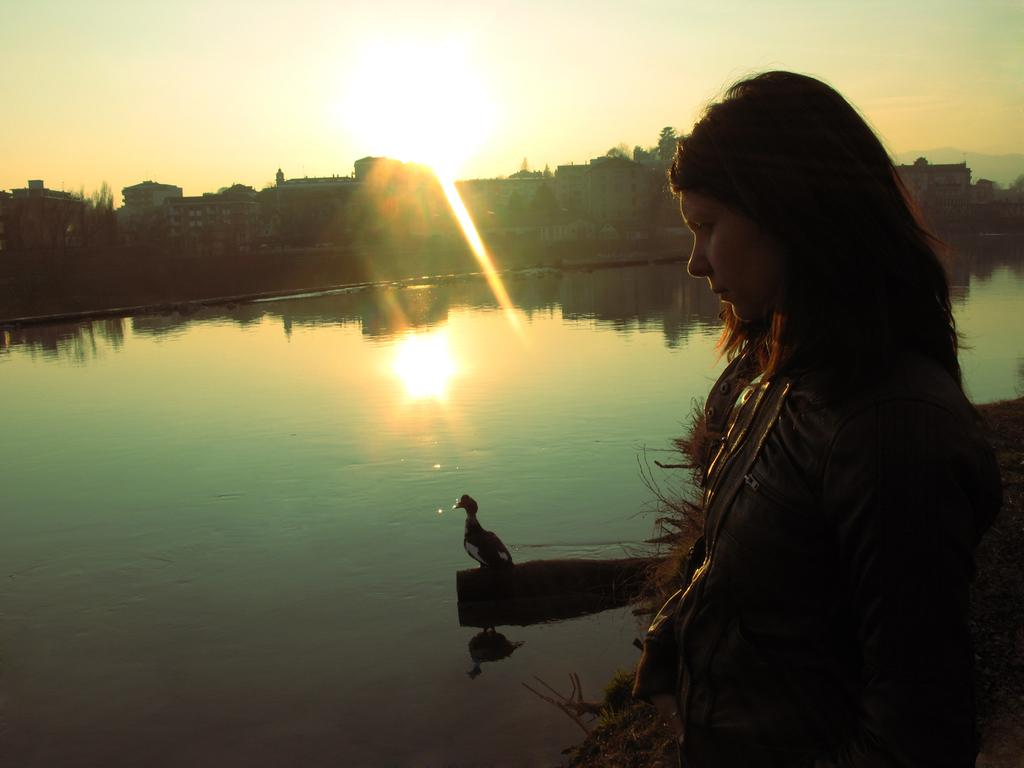What is the woman doing in the image? The woman is standing near the water in the image. What else can be seen in the water? There is a bird standing in the water. What can be seen in the distance behind the woman and the bird? There are buildings in the background of the image. What is visible above the buildings and the bird? The sky is visible in the background of the image. How long does it take for the cap to play a song in the image? There is no cap or any indication of music playing in the image. 